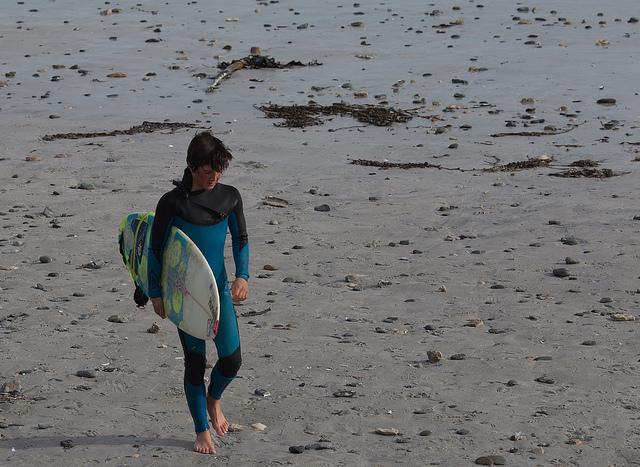Is this board for standing on?
Short answer required. Yes. What color is the kid's wetsuit?
Answer briefly. Blue. How many people in the photo?
Concise answer only. 1. What is the woman holding?
Quick response, please. Surfboard. What is the girl holding?
Keep it brief. Surfboard. Are there two people holding surfboards?
Keep it brief. No. Is this man trying to fly the kite?
Concise answer only. No. How many toes on each foot?
Keep it brief. 5. Can you see the waves?
Quick response, please. No. How many people are holding surfboards?
Keep it brief. 1. What kind of swimsuit is the woman wearing?
Short answer required. Wetsuit. What is painted at the top of the surfboard?
Concise answer only. Design. Is there a string on the kite?
Keep it brief. No. What is the lady holding?
Quick response, please. Surfboard. What color is the surfboard?
Answer briefly. White. What does the surfboard say?
Give a very brief answer. Nothing. What is on the ground next to this person?
Short answer required. Sand. Did they just come from surfing or are going surfing?
Concise answer only. Going. Is there fine sand?
Give a very brief answer. Yes. Is the sand wet?
Give a very brief answer. Yes. Is the person wearing socks?
Concise answer only. No. What is the girl wearing?
Concise answer only. Wetsuit. 